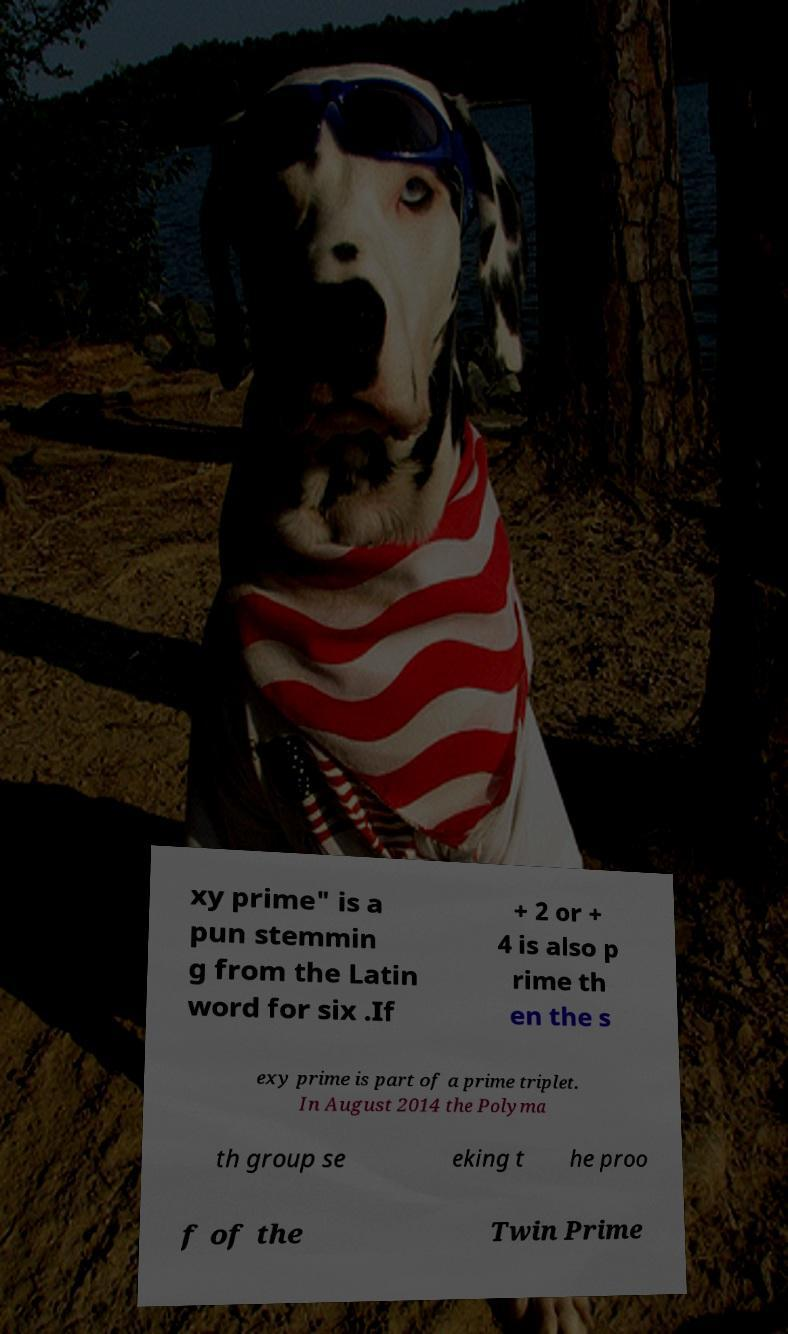What messages or text are displayed in this image? I need them in a readable, typed format. xy prime" is a pun stemmin g from the Latin word for six .If + 2 or + 4 is also p rime th en the s exy prime is part of a prime triplet. In August 2014 the Polyma th group se eking t he proo f of the Twin Prime 